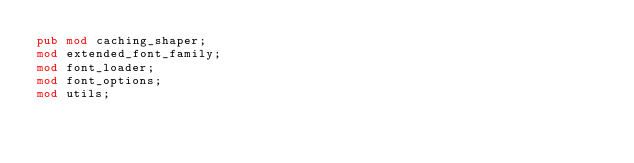Convert code to text. <code><loc_0><loc_0><loc_500><loc_500><_Rust_>pub mod caching_shaper;
mod extended_font_family;
mod font_loader;
mod font_options;
mod utils;
</code> 